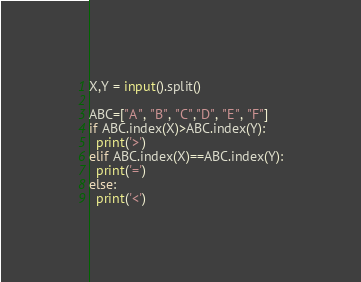Convert code to text. <code><loc_0><loc_0><loc_500><loc_500><_Python_>X,Y = input().split()

ABC=["A", "B", "C","D", "E", "F"]
if ABC.index(X)>ABC.index(Y):
  print('>')
elif ABC.index(X)==ABC.index(Y):
  print('=')
else:
  print('<')</code> 